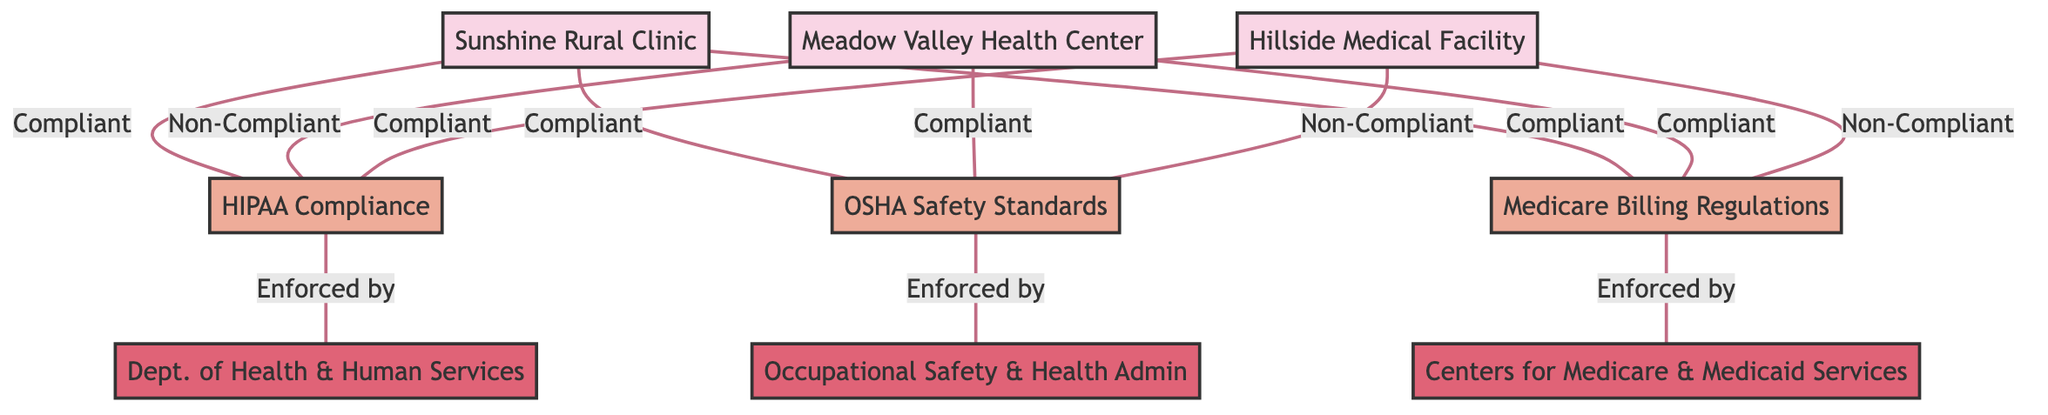What is the total number of clinics represented in the diagram? The diagram shows three clinics: Sunshine Rural Clinic, Meadow Valley Health Center, and Hillside Medical Facility. Counting each node labeled as a clinic gives a total of three.
Answer: 3 Which regulation is enforced by the Department of Health and Human Services? According to the diagram, the HIPAA Compliance regulation is linked to the Department of Health and Human Services by an "Enforced by" edge. Thus, HIPAA Compliance is the regulation enforced by this department.
Answer: HIPAA Compliance How many regulations are depicted in the diagram? The diagram contains three regulations: HIPAA Compliance, OSHA Safety Standards, and Medicare Billing Regulations. By counting these nodes, we find there are a total of three regulations shown in the diagram.
Answer: 3 What is the compliance status of Hillside Medical Facility with respect to OSHA Safety Standards? The edge connecting Hillside Medical Facility and OSHA Safety Standards indicates a "Non-Compliant" status. Therefore, the compliance status of Hillside Medical Facility with OSHA Safety Standards is non-compliant.
Answer: Non-Compliant Which clinic has the highest number of compliance with the regulations mentioned? By analyzing the edges from each clinic to regulations, both Sunshine Rural Clinic and Meadow Valley Health Center are compliant with all three regulations. Since Hillside Medical Facility is non-compliant with all three, Sunshine Rural and Meadow Valley Clinics have the highest compliance.
Answer: Sunshine Rural Clinic, Meadow Valley Health Center How many compliance statuses are non-compliant across all clinics? By reviewing the compliance statuses depicted in the diagram for each clinic: Meadow Valley Health Center is non-compliant for HIPAA Compliance, and Hillside Medical Facility is non-compliant for OSHA Safety Standards and Medicare Billing Regulations. Therefore, a total of three non-compliance statuses are present across clinics.
Answer: 3 Which regulator is responsible for enforcing Medicare Billing Regulations? The Medicare Billing Regulations are linked to the Centers for Medicare & Medicaid Services with an "Enforced by" edge in the diagram, indicating that this regulator is responsible for enforcing this regulation.
Answer: Centers for Medicare & Medicaid Services How many edges connect Sunshine Rural Clinic to regulations? The diagram shows three edges connecting Sunshine Rural Clinic: one to HIPAA Compliance, one to OSHA Safety Standards, and one to Medicare Billing Regulations. Thus, there are a total of three edges connecting Sunshine Rural Clinic to regulations.
Answer: 3 What is the relationship type between Hillside Medical Facility and HIPAA Compliance? The relationship type connecting Hillside Medical Facility and HIPAA Compliance is indicated by "Compliant" on the edge. Therefore, the relationship is that Hillside Medical Facility is compliant with HIPAA Compliance regulations.
Answer: Compliant 